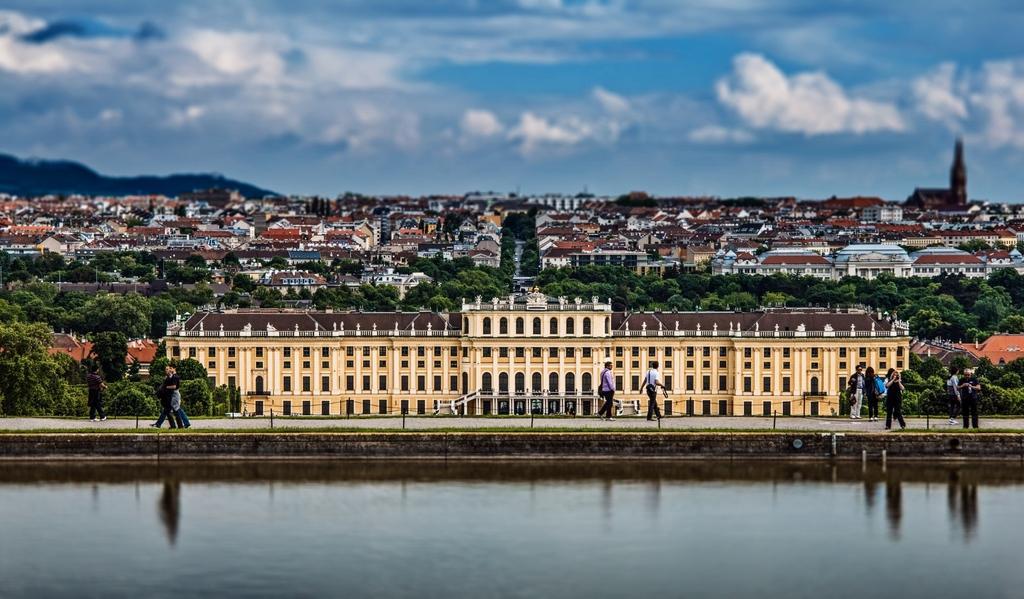Could you give a brief overview of what you see in this image? In this image we can see some houses, trees, plants, there are a few people, some of them are walking on the road, there are some poles, also we can see the water, mountains, and the cloudy sky. 